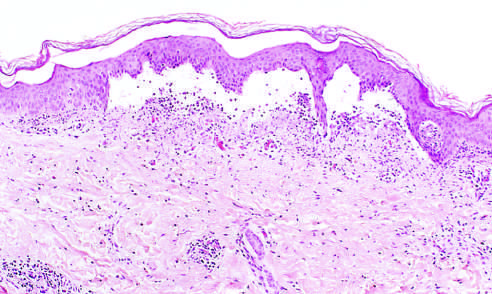what is separated from the dermis by a focal collection of serous effusion?
Answer the question using a single word or phrase. The epidermis 